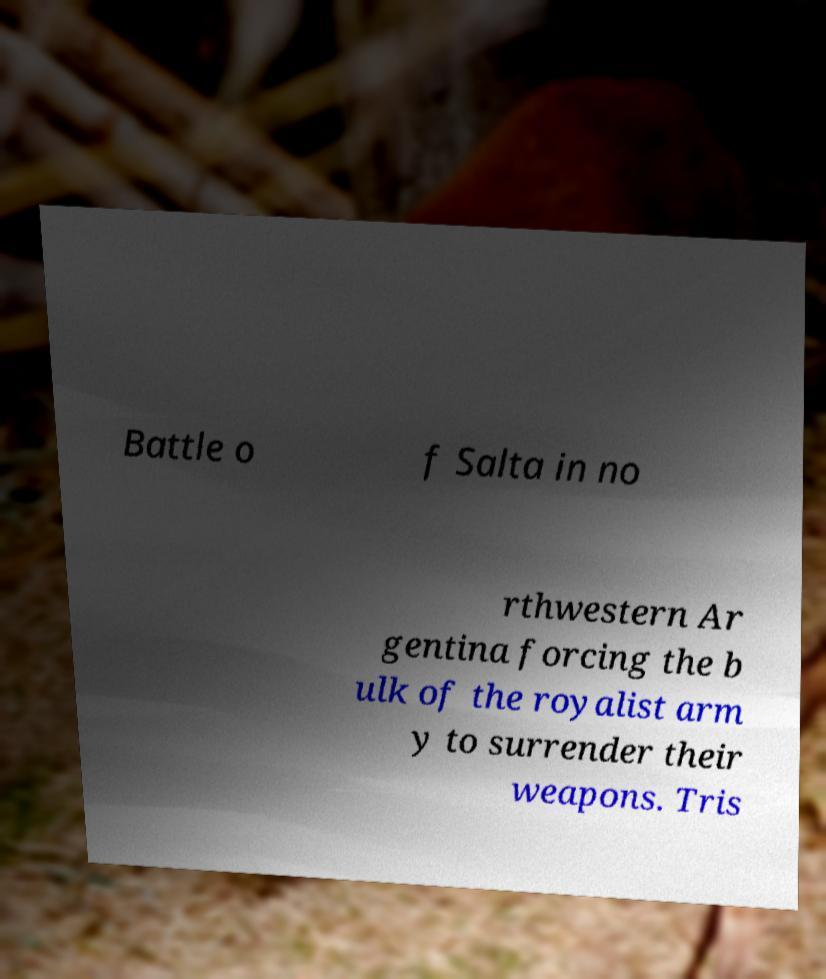What messages or text are displayed in this image? I need them in a readable, typed format. Battle o f Salta in no rthwestern Ar gentina forcing the b ulk of the royalist arm y to surrender their weapons. Tris 